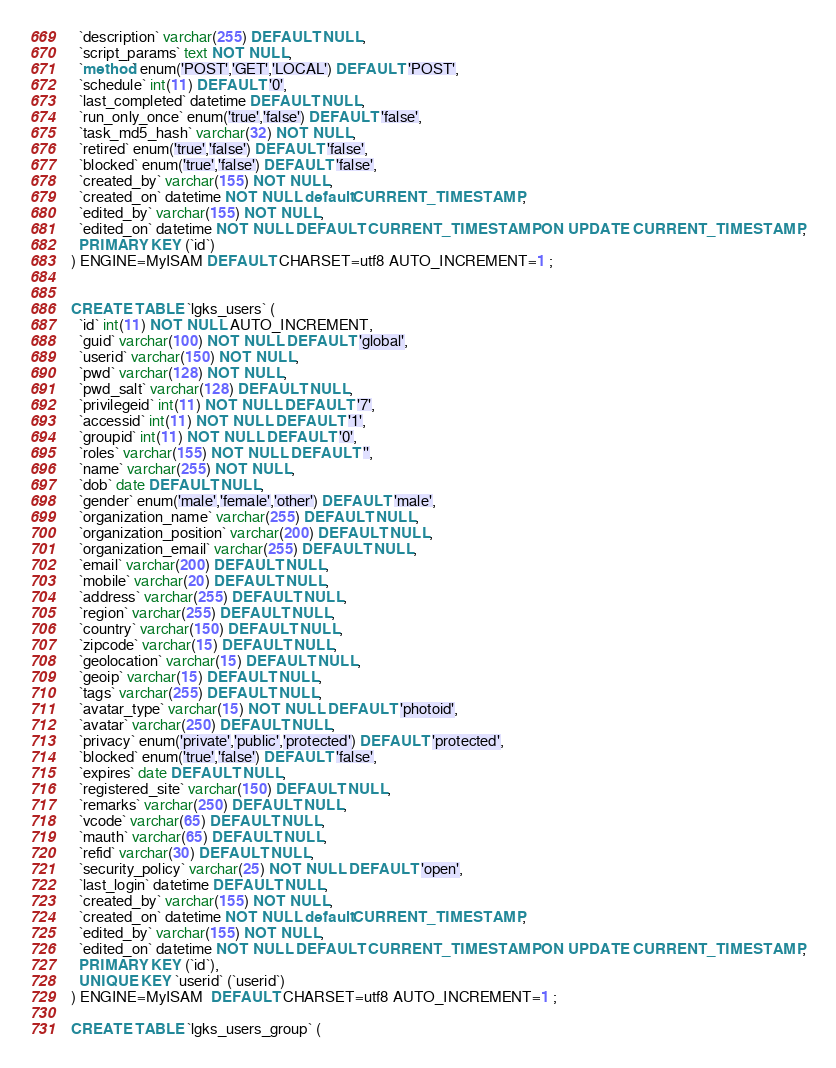Convert code to text. <code><loc_0><loc_0><loc_500><loc_500><_SQL_>  `description` varchar(255) DEFAULT NULL,
  `script_params` text NOT NULL,
  `method` enum('POST','GET','LOCAL') DEFAULT 'POST',
  `schedule` int(11) DEFAULT '0',
  `last_completed` datetime DEFAULT NULL,
  `run_only_once` enum('true','false') DEFAULT 'false',
  `task_md5_hash` varchar(32) NOT NULL,
  `retired` enum('true','false') DEFAULT 'false',
  `blocked` enum('true','false') DEFAULT 'false',
  `created_by` varchar(155) NOT NULL,
  `created_on` datetime NOT NULL default CURRENT_TIMESTAMP,
  `edited_by` varchar(155) NOT NULL,
  `edited_on` datetime NOT NULL DEFAULT CURRENT_TIMESTAMP ON UPDATE CURRENT_TIMESTAMP,
  PRIMARY KEY (`id`)
) ENGINE=MyISAM DEFAULT CHARSET=utf8 AUTO_INCREMENT=1 ;


CREATE TABLE `lgks_users` (
  `id` int(11) NOT NULL AUTO_INCREMENT,
  `guid` varchar(100) NOT NULL DEFAULT 'global',
  `userid` varchar(150) NOT NULL,
  `pwd` varchar(128) NOT NULL,
  `pwd_salt` varchar(128) DEFAULT NULL,
  `privilegeid` int(11) NOT NULL DEFAULT '7',
  `accessid` int(11) NOT NULL DEFAULT '1',
  `groupid` int(11) NOT NULL DEFAULT '0',
  `roles` varchar(155) NOT NULL DEFAULT '',
  `name` varchar(255) NOT NULL,
  `dob` date DEFAULT NULL,
  `gender` enum('male','female','other') DEFAULT 'male',
  `organization_name` varchar(255) DEFAULT NULL,
  `organization_position` varchar(200) DEFAULT NULL,
  `organization_email` varchar(255) DEFAULT NULL,
  `email` varchar(200) DEFAULT NULL,
  `mobile` varchar(20) DEFAULT NULL,
  `address` varchar(255) DEFAULT NULL,
  `region` varchar(255) DEFAULT NULL,
  `country` varchar(150) DEFAULT NULL,
  `zipcode` varchar(15) DEFAULT NULL,
  `geolocation` varchar(15) DEFAULT NULL,
  `geoip` varchar(15) DEFAULT NULL,
  `tags` varchar(255) DEFAULT NULL,
  `avatar_type` varchar(15) NOT NULL DEFAULT 'photoid',
  `avatar` varchar(250) DEFAULT NULL,
  `privacy` enum('private','public','protected') DEFAULT 'protected',
  `blocked` enum('true','false') DEFAULT 'false',
  `expires` date DEFAULT NULL,
  `registered_site` varchar(150) DEFAULT NULL,
  `remarks` varchar(250) DEFAULT NULL,
  `vcode` varchar(65) DEFAULT NULL,
  `mauth` varchar(65) DEFAULT NULL,
  `refid` varchar(30) DEFAULT NULL,
  `security_policy` varchar(25) NOT NULL DEFAULT 'open',
  `last_login` datetime DEFAULT NULL,
  `created_by` varchar(155) NOT NULL,
  `created_on` datetime NOT NULL default CURRENT_TIMESTAMP,
  `edited_by` varchar(155) NOT NULL,
  `edited_on` datetime NOT NULL DEFAULT CURRENT_TIMESTAMP ON UPDATE CURRENT_TIMESTAMP,
  PRIMARY KEY (`id`),
  UNIQUE KEY `userid` (`userid`)
) ENGINE=MyISAM  DEFAULT CHARSET=utf8 AUTO_INCREMENT=1 ;

CREATE TABLE `lgks_users_group` (</code> 